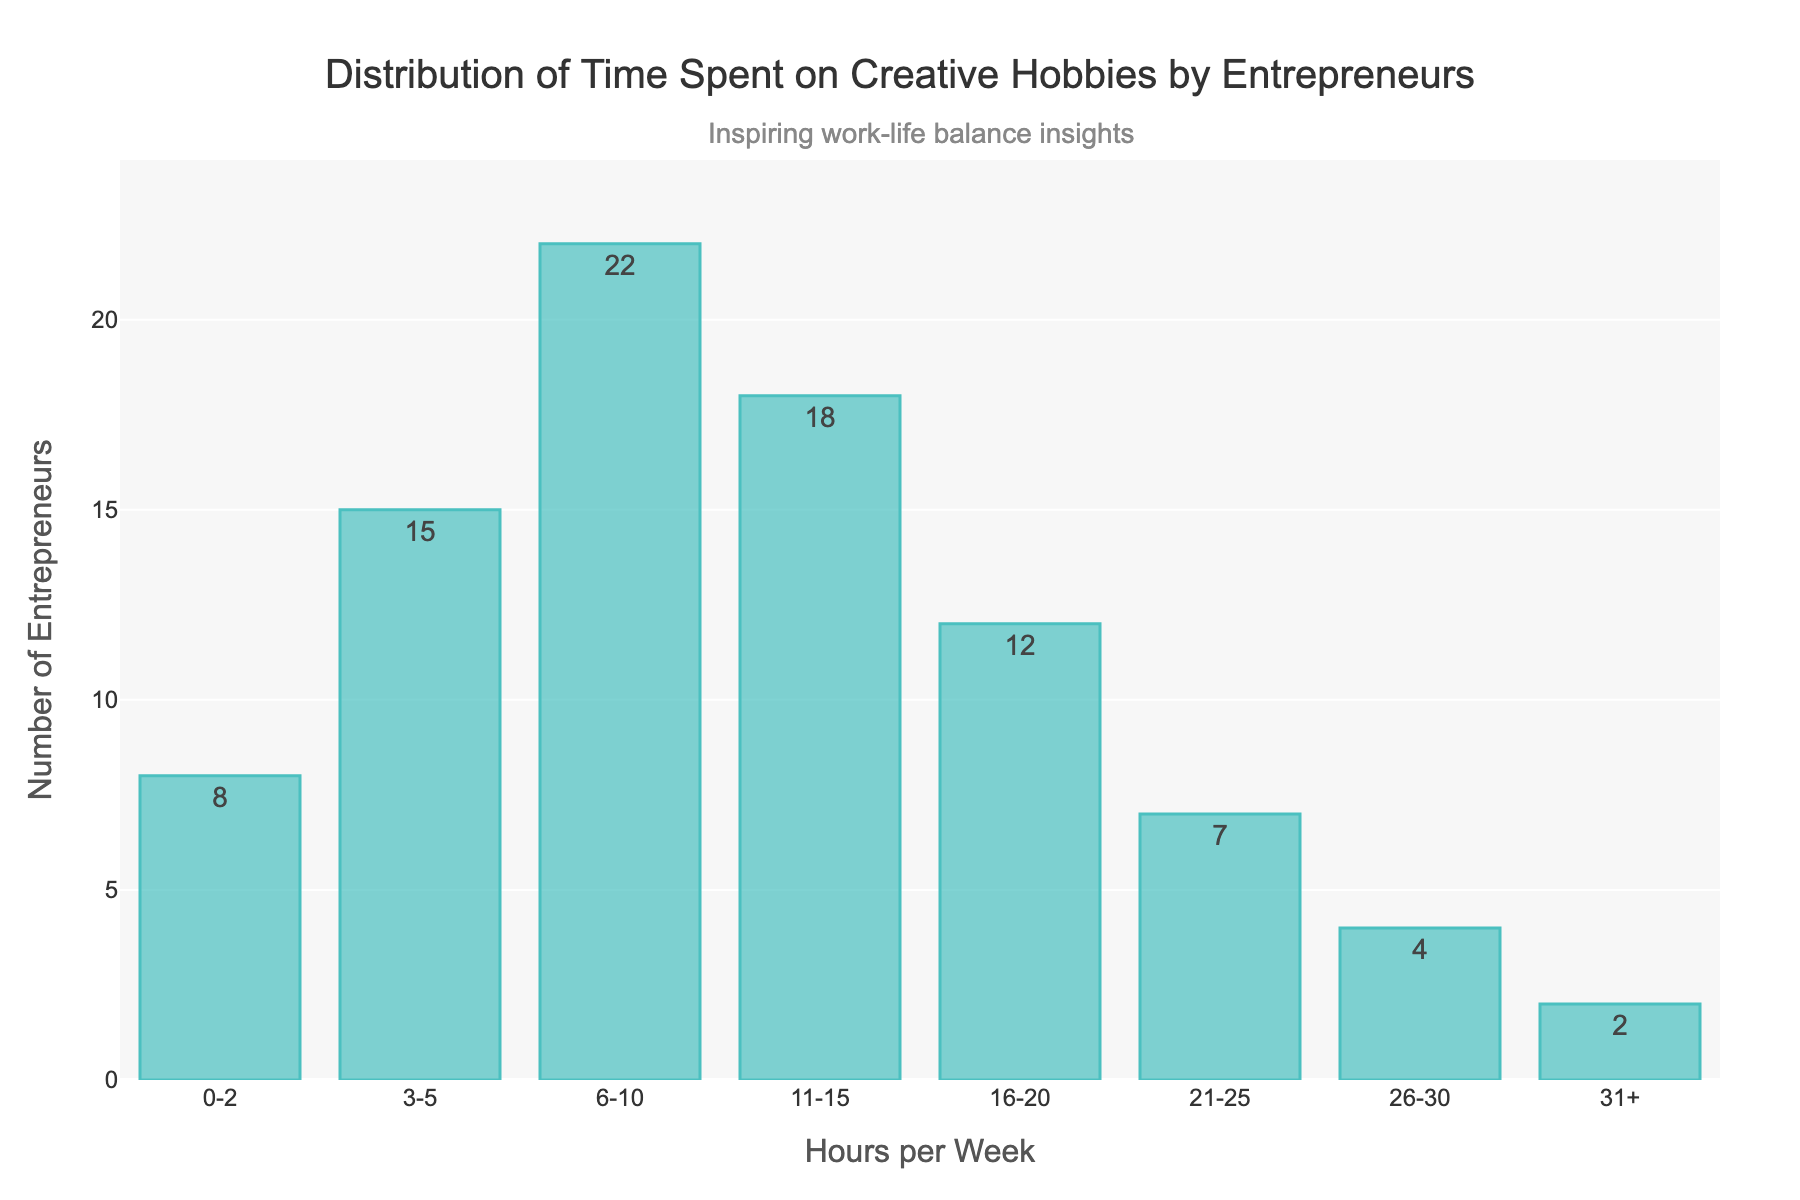What is the title of the histogram? The title is located at the top center of the histogram. It is "Distribution of Time Spent on Creative Hobbies by Entrepreneurs".
Answer: Distribution of Time Spent on Creative Hobbies by Entrepreneurs How many entrepreneurs spend 11-15 hours per week on creative hobbies? Refer to the bar corresponding to 11-15 hours per week. The height of the bar and the text label both show the number of entrepreneurs.
Answer: 18 Which range of hours has the highest number of entrepreneurs? Look for the tallest bar in the histogram. The tallest bar represents the 6-10 hours per week range.
Answer: 6-10 hours per week How many entrepreneurs spend more than 20 hours per week on creative hobbies? Add the values of the bars that represent hours greater than 20. This includes the ranges 21-25, 26-30, and 31+. The numbers are 7, 4, and 2, respectively. Summing these yields 7+4+2=13.
Answer: 13 What is the combined number of entrepreneurs who spend between 3 and 15 hours per week on creative hobbies? Add the numbers of entrepreneurs in the ranges 3-5, 6-10, and 11-15. These values are 15, 22, and 18, respectively. Summing these yields 15+22+18=55.
Answer: 55 Which hours range has the least number of entrepreneurs? Look for the shortest bar in the histogram. The shortest bar represents the 31+ hours per week range.
Answer: 31+ hours per week What is the average number of entrepreneurs per hour range shown in the histogram? Add the numbers of entrepreneurs for all ranges and divide by the total number of ranges. The values are 8, 15, 22, 18, 12, 7, 4, and 2. The sum is 8+15+22+18+12+7+4+2=88. There are 8 ranges, so the average is 88/8=11.
Answer: 11 How do the number of entrepreneurs who spend 0-2 hours compare to those who spend 26-30 hours on creative hobbies? Compare the heights of the bars for 0-2 hours and 26-30 hours. The 0-2 hours bar is taller than the 26-30 hours bar, with 8 entrepreneurs versus 4 entrepreneurs.
Answer: More in 0-2 hours If you combine the entrepreneurs spending 0-2, 3-5, and 6-10 hours, what percentage of the total entrepreneurs does this constitute? First, calculate the number of entrepreneurs in these ranges, which are 8, 15, and 22 respectively. Their sum is 8+15+22=45. The total number of entrepreneurs is 88 (sum of all bars). The percentage is (45/88)*100 ≈ 51.14%.
Answer: ~51.14% Are there more entrepreneurs spending 16-20 hours or 21-30 hours on creative hobbies? Compare the sums of the respective bars. For 16-20 hours, there are 12 entrepreneurs. For 21-30 hours (sum of 21-25 and 26-30), there are 7+4=11 entrepreneurs. Therefore, more entrepreneurs spend 16-20 hours.
Answer: 16-20 hours 